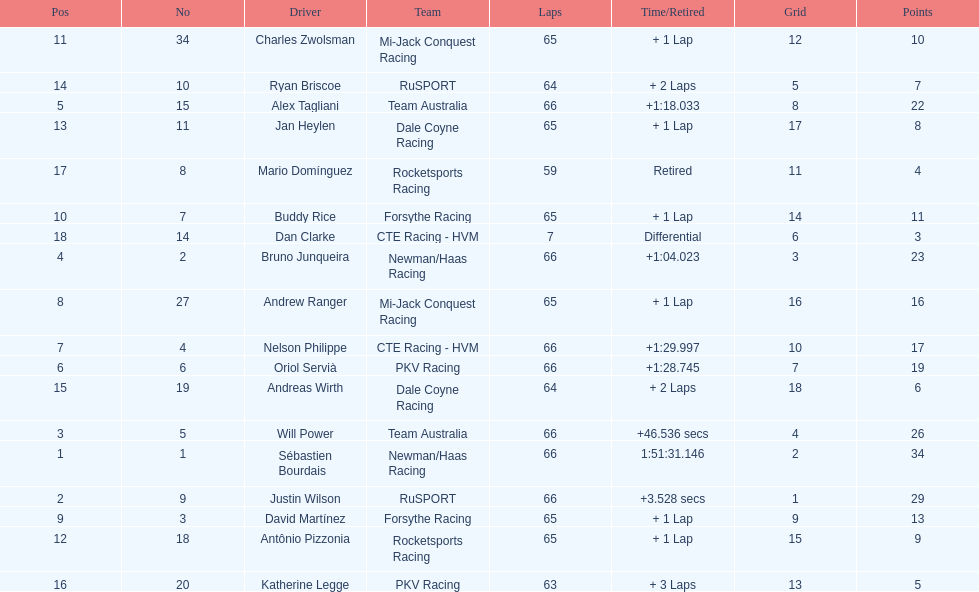Which country is represented by the most drivers? United Kingdom. 